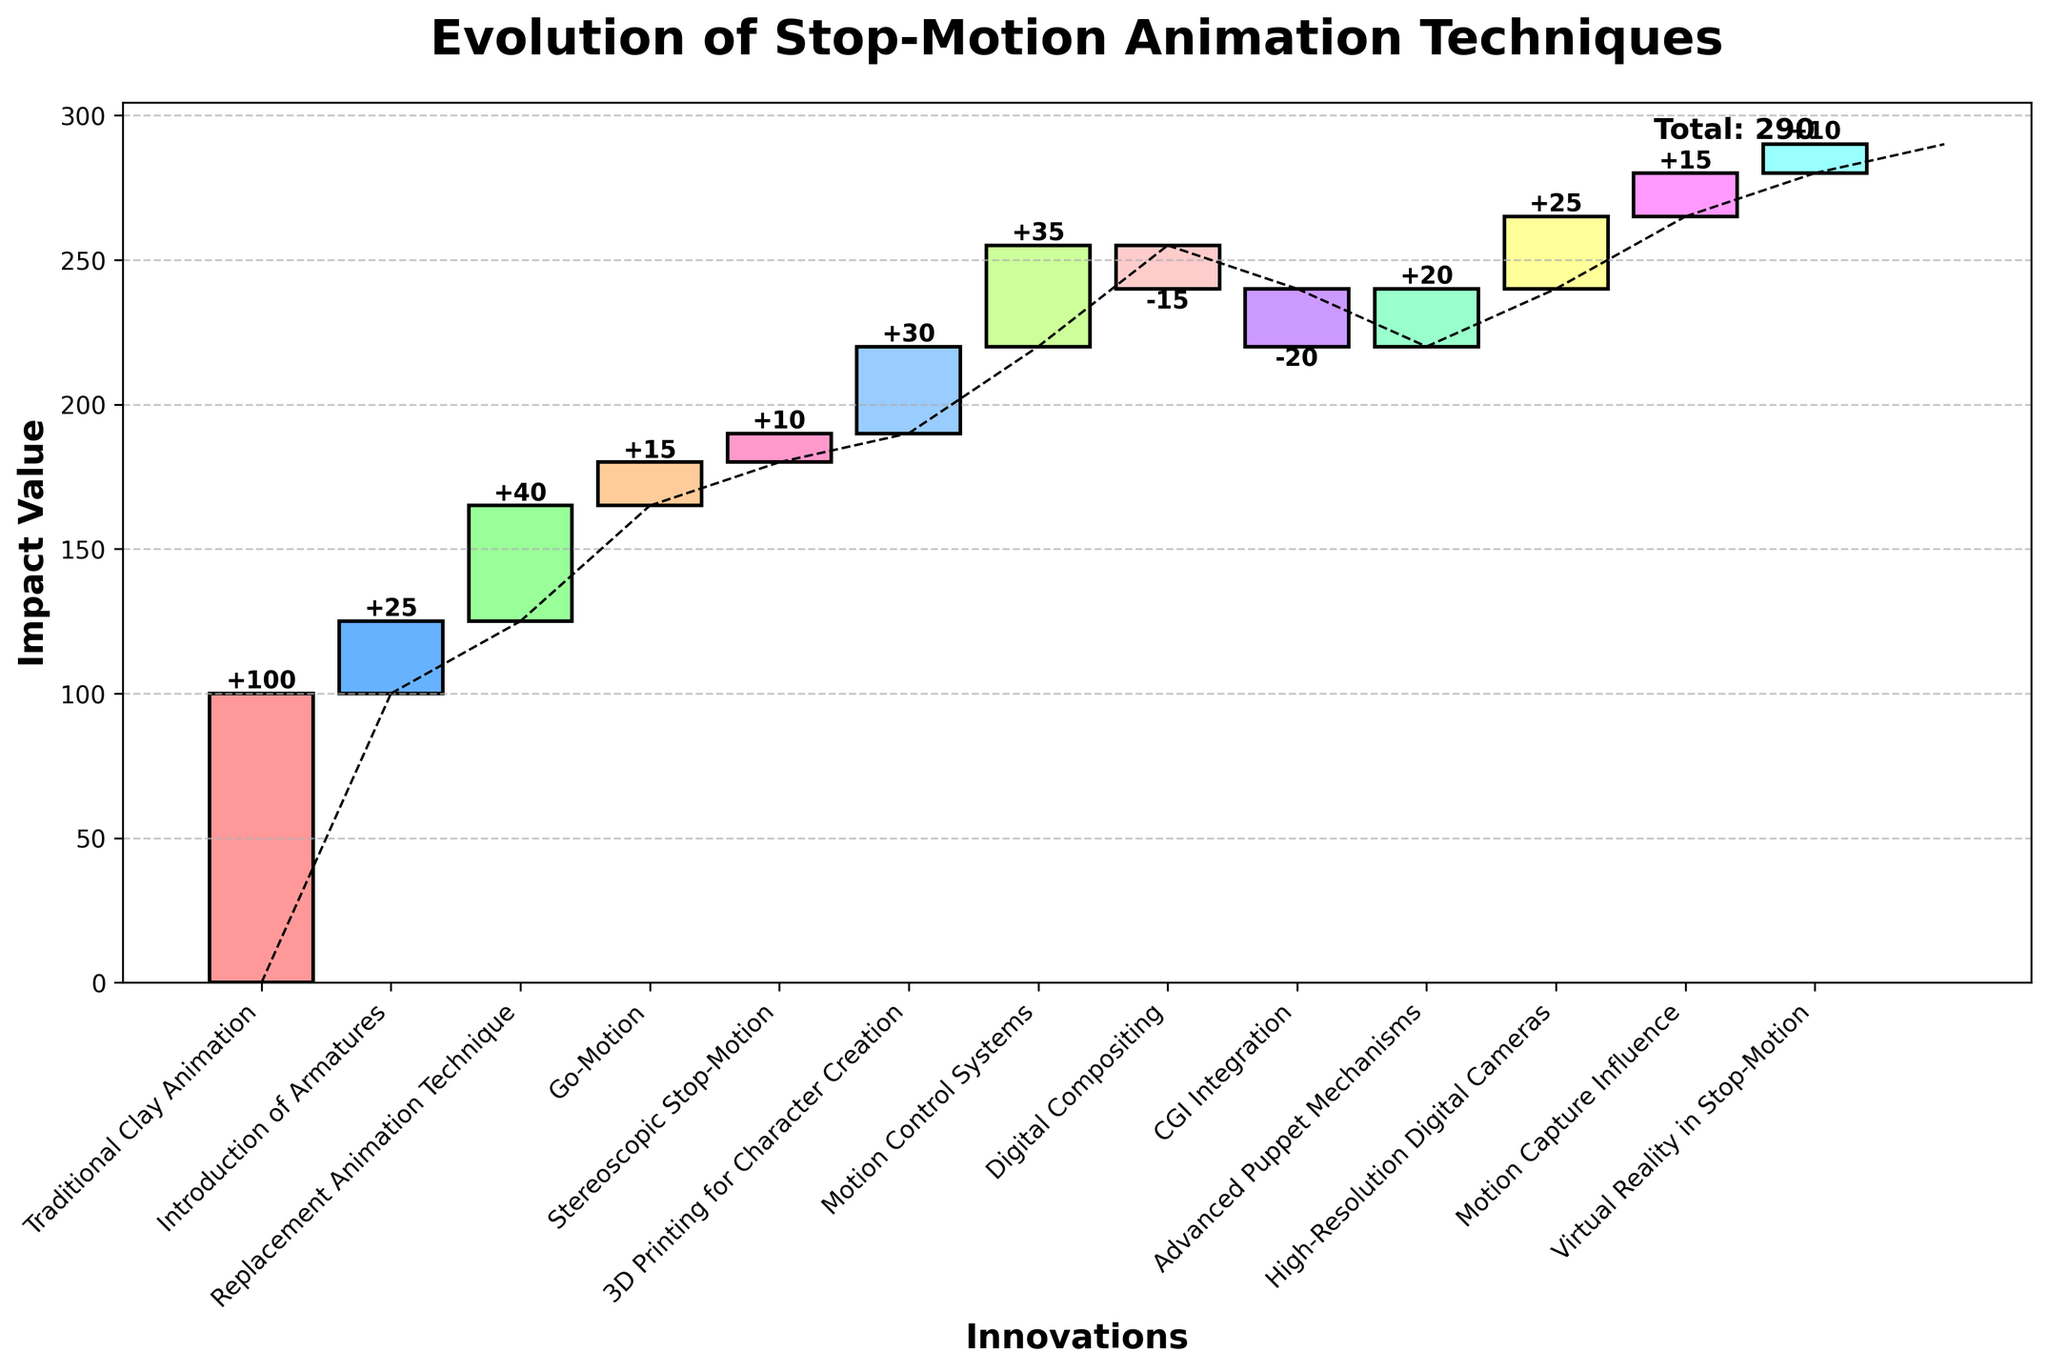What is the title of the figure? The title of the figure is shown at the top and reads 'Evolution of Stop-Motion Animation Techniques'.
Answer: Evolution of Stop-Motion Animation Techniques Which technique has the highest impact value and what is it? By inspecting the bars, it is clear that 'Traditional Clay Animation' has the highest impact value, which is shown by the highest bar.
Answer: Traditional Clay Animation: 100 Which innovation had the most negative impact and how much was it? Among the bars with a negative impact, 'CGI Integration' has the most negative value. This can be observed as it reaches the lowest point on the vertical axis.
Answer: CGI Integration: -20 What is the cumulative impact value after the introduction of armatures? To get the cumulative impact value after 'Introduction of Armatures', we add the impact values of 'Traditional Clay Animation' and 'Introduction of Armatures'. So, 100 + 25 = 125.
Answer: 125 What is the total impact value of all stop-motion animation techniques over the past century? The total impact value is indicated at the end of the chart and labeled as 'Total: 290'.
Answer: 290 How many categories are plotted in the waterfall chart? The number of categories is determined by counting the bars in the chart. There are 13 bars representing different innovations.
Answer: 13 Calculate the net impact of 'Digital Compositing' and 'CGI Integration'. The net impact is the sum of the values of 'Digital Compositing' and 'CGI Integration', which are -15 and -20 respectively. So, -15 + (-20) = -35.
Answer: -35 Which innovations each contributed an impact value greater than 30? By checking each bar's value, we find that 'Traditional Clay Animation', 'Replacement Animation Technique', and 'Motion Control Systems' each have impact values greater than 30.
Answer: Traditional Clay Animation, Replacement Animation Technique, Motion Control Systems What is the incremental impact value of 'Motion Control Systems' following '3D Printing for Character Creation'? The incremental impact value is calculated by adding '3D Printing for Character Creation' and 'Motion Control Systems', which are 30 and 35 respectively. So, 30 + 35 = 65.
Answer: 65 Which innovations have a cumulative impact value between 100 and 150, after including their impacts? The cumulative impact values quickly checked in sequence: 'Traditional Clay Animation' (100), adding 'Introduction of Armatures' makes it 125, and adding 'Replacement Animation Technique' makes it go beyond 150 to 165. Therefore, 'Introduction of Armatures' fits the range.
Answer: Introduction of Armatures 